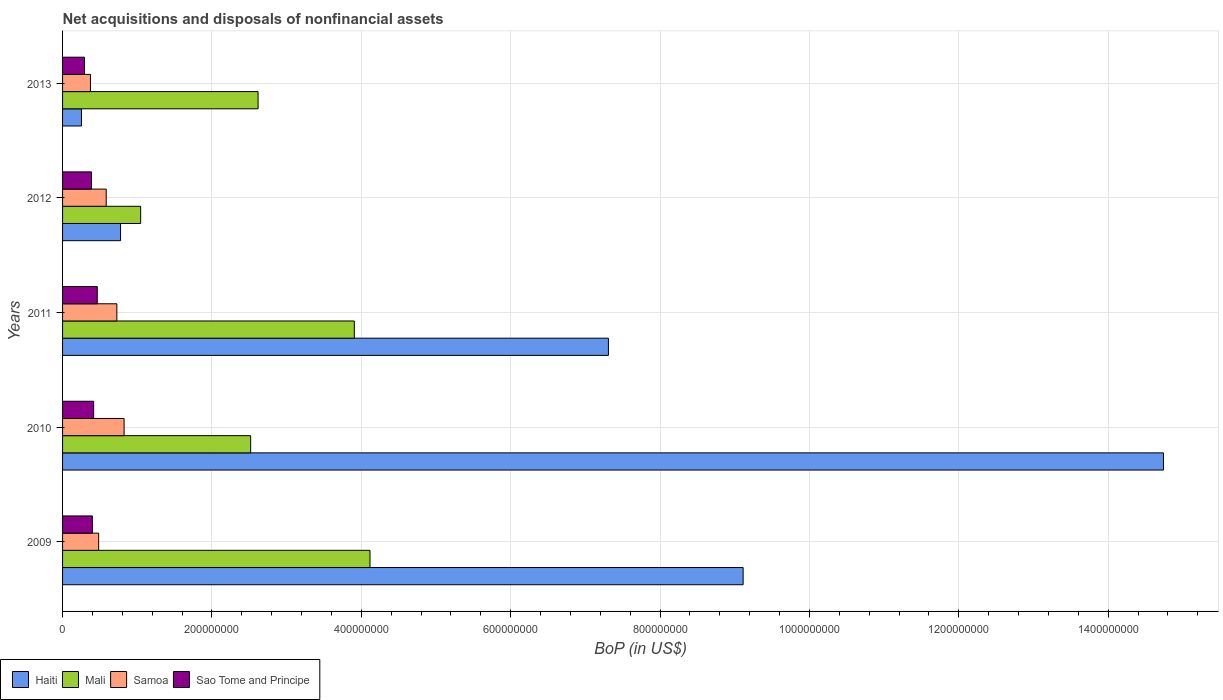How many groups of bars are there?
Your answer should be very brief. 5. Are the number of bars on each tick of the Y-axis equal?
Ensure brevity in your answer.  Yes. How many bars are there on the 3rd tick from the top?
Offer a very short reply. 4. How many bars are there on the 5th tick from the bottom?
Keep it short and to the point. 4. What is the Balance of Payments in Sao Tome and Principe in 2010?
Offer a terse response. 4.16e+07. Across all years, what is the maximum Balance of Payments in Mali?
Your answer should be very brief. 4.12e+08. Across all years, what is the minimum Balance of Payments in Mali?
Give a very brief answer. 1.05e+08. In which year was the Balance of Payments in Haiti maximum?
Ensure brevity in your answer.  2010. What is the total Balance of Payments in Mali in the graph?
Give a very brief answer. 1.42e+09. What is the difference between the Balance of Payments in Sao Tome and Principe in 2010 and that in 2013?
Give a very brief answer. 1.22e+07. What is the difference between the Balance of Payments in Haiti in 2011 and the Balance of Payments in Mali in 2012?
Offer a terse response. 6.26e+08. What is the average Balance of Payments in Sao Tome and Principe per year?
Keep it short and to the point. 3.92e+07. In the year 2012, what is the difference between the Balance of Payments in Samoa and Balance of Payments in Mali?
Offer a very short reply. -4.61e+07. In how many years, is the Balance of Payments in Samoa greater than 1200000000 US$?
Offer a terse response. 0. What is the ratio of the Balance of Payments in Mali in 2010 to that in 2011?
Offer a terse response. 0.64. Is the Balance of Payments in Mali in 2010 less than that in 2011?
Provide a short and direct response. Yes. Is the difference between the Balance of Payments in Samoa in 2009 and 2012 greater than the difference between the Balance of Payments in Mali in 2009 and 2012?
Offer a very short reply. No. What is the difference between the highest and the second highest Balance of Payments in Sao Tome and Principe?
Keep it short and to the point. 4.85e+06. What is the difference between the highest and the lowest Balance of Payments in Samoa?
Give a very brief answer. 4.50e+07. In how many years, is the Balance of Payments in Mali greater than the average Balance of Payments in Mali taken over all years?
Make the answer very short. 2. Is it the case that in every year, the sum of the Balance of Payments in Samoa and Balance of Payments in Sao Tome and Principe is greater than the sum of Balance of Payments in Mali and Balance of Payments in Haiti?
Offer a terse response. No. What does the 1st bar from the top in 2011 represents?
Your answer should be compact. Sao Tome and Principe. What does the 3rd bar from the bottom in 2010 represents?
Give a very brief answer. Samoa. How many bars are there?
Keep it short and to the point. 20. How many years are there in the graph?
Make the answer very short. 5. What is the difference between two consecutive major ticks on the X-axis?
Give a very brief answer. 2.00e+08. Are the values on the major ticks of X-axis written in scientific E-notation?
Your answer should be very brief. No. Does the graph contain grids?
Provide a short and direct response. Yes. How many legend labels are there?
Offer a terse response. 4. What is the title of the graph?
Provide a succinct answer. Net acquisitions and disposals of nonfinancial assets. Does "Sub-Saharan Africa (developing only)" appear as one of the legend labels in the graph?
Your answer should be compact. No. What is the label or title of the X-axis?
Offer a terse response. BoP (in US$). What is the label or title of the Y-axis?
Ensure brevity in your answer.  Years. What is the BoP (in US$) of Haiti in 2009?
Offer a very short reply. 9.11e+08. What is the BoP (in US$) in Mali in 2009?
Your answer should be compact. 4.12e+08. What is the BoP (in US$) of Samoa in 2009?
Ensure brevity in your answer.  4.83e+07. What is the BoP (in US$) of Sao Tome and Principe in 2009?
Make the answer very short. 3.99e+07. What is the BoP (in US$) of Haiti in 2010?
Your response must be concise. 1.47e+09. What is the BoP (in US$) in Mali in 2010?
Your response must be concise. 2.52e+08. What is the BoP (in US$) of Samoa in 2010?
Your answer should be compact. 8.24e+07. What is the BoP (in US$) of Sao Tome and Principe in 2010?
Keep it short and to the point. 4.16e+07. What is the BoP (in US$) in Haiti in 2011?
Provide a succinct answer. 7.31e+08. What is the BoP (in US$) of Mali in 2011?
Provide a short and direct response. 3.91e+08. What is the BoP (in US$) in Samoa in 2011?
Give a very brief answer. 7.27e+07. What is the BoP (in US$) in Sao Tome and Principe in 2011?
Keep it short and to the point. 4.65e+07. What is the BoP (in US$) in Haiti in 2012?
Offer a very short reply. 7.77e+07. What is the BoP (in US$) in Mali in 2012?
Make the answer very short. 1.05e+08. What is the BoP (in US$) of Samoa in 2012?
Make the answer very short. 5.84e+07. What is the BoP (in US$) of Sao Tome and Principe in 2012?
Ensure brevity in your answer.  3.87e+07. What is the BoP (in US$) in Haiti in 2013?
Provide a short and direct response. 2.53e+07. What is the BoP (in US$) of Mali in 2013?
Your response must be concise. 2.62e+08. What is the BoP (in US$) of Samoa in 2013?
Ensure brevity in your answer.  3.74e+07. What is the BoP (in US$) in Sao Tome and Principe in 2013?
Keep it short and to the point. 2.94e+07. Across all years, what is the maximum BoP (in US$) of Haiti?
Offer a terse response. 1.47e+09. Across all years, what is the maximum BoP (in US$) in Mali?
Keep it short and to the point. 4.12e+08. Across all years, what is the maximum BoP (in US$) of Samoa?
Offer a very short reply. 8.24e+07. Across all years, what is the maximum BoP (in US$) in Sao Tome and Principe?
Make the answer very short. 4.65e+07. Across all years, what is the minimum BoP (in US$) in Haiti?
Your response must be concise. 2.53e+07. Across all years, what is the minimum BoP (in US$) in Mali?
Give a very brief answer. 1.05e+08. Across all years, what is the minimum BoP (in US$) in Samoa?
Make the answer very short. 3.74e+07. Across all years, what is the minimum BoP (in US$) in Sao Tome and Principe?
Provide a succinct answer. 2.94e+07. What is the total BoP (in US$) in Haiti in the graph?
Your answer should be compact. 3.22e+09. What is the total BoP (in US$) of Mali in the graph?
Keep it short and to the point. 1.42e+09. What is the total BoP (in US$) of Samoa in the graph?
Provide a succinct answer. 2.99e+08. What is the total BoP (in US$) in Sao Tome and Principe in the graph?
Provide a short and direct response. 1.96e+08. What is the difference between the BoP (in US$) in Haiti in 2009 and that in 2010?
Ensure brevity in your answer.  -5.63e+08. What is the difference between the BoP (in US$) in Mali in 2009 and that in 2010?
Offer a very short reply. 1.60e+08. What is the difference between the BoP (in US$) in Samoa in 2009 and that in 2010?
Keep it short and to the point. -3.41e+07. What is the difference between the BoP (in US$) of Sao Tome and Principe in 2009 and that in 2010?
Your answer should be compact. -1.75e+06. What is the difference between the BoP (in US$) in Haiti in 2009 and that in 2011?
Make the answer very short. 1.80e+08. What is the difference between the BoP (in US$) of Mali in 2009 and that in 2011?
Provide a short and direct response. 2.10e+07. What is the difference between the BoP (in US$) in Samoa in 2009 and that in 2011?
Your response must be concise. -2.44e+07. What is the difference between the BoP (in US$) of Sao Tome and Principe in 2009 and that in 2011?
Your answer should be compact. -6.60e+06. What is the difference between the BoP (in US$) in Haiti in 2009 and that in 2012?
Your answer should be compact. 8.34e+08. What is the difference between the BoP (in US$) of Mali in 2009 and that in 2012?
Keep it short and to the point. 3.07e+08. What is the difference between the BoP (in US$) of Samoa in 2009 and that in 2012?
Offer a terse response. -1.01e+07. What is the difference between the BoP (in US$) in Sao Tome and Principe in 2009 and that in 2012?
Your response must be concise. 1.17e+06. What is the difference between the BoP (in US$) in Haiti in 2009 and that in 2013?
Provide a succinct answer. 8.86e+08. What is the difference between the BoP (in US$) in Mali in 2009 and that in 2013?
Your response must be concise. 1.50e+08. What is the difference between the BoP (in US$) in Samoa in 2009 and that in 2013?
Make the answer very short. 1.10e+07. What is the difference between the BoP (in US$) of Sao Tome and Principe in 2009 and that in 2013?
Give a very brief answer. 1.05e+07. What is the difference between the BoP (in US$) in Haiti in 2010 and that in 2011?
Keep it short and to the point. 7.43e+08. What is the difference between the BoP (in US$) in Mali in 2010 and that in 2011?
Make the answer very short. -1.39e+08. What is the difference between the BoP (in US$) of Samoa in 2010 and that in 2011?
Provide a short and direct response. 9.68e+06. What is the difference between the BoP (in US$) of Sao Tome and Principe in 2010 and that in 2011?
Your answer should be very brief. -4.85e+06. What is the difference between the BoP (in US$) in Haiti in 2010 and that in 2012?
Keep it short and to the point. 1.40e+09. What is the difference between the BoP (in US$) of Mali in 2010 and that in 2012?
Your response must be concise. 1.47e+08. What is the difference between the BoP (in US$) in Samoa in 2010 and that in 2012?
Provide a succinct answer. 2.39e+07. What is the difference between the BoP (in US$) of Sao Tome and Principe in 2010 and that in 2012?
Provide a short and direct response. 2.92e+06. What is the difference between the BoP (in US$) of Haiti in 2010 and that in 2013?
Provide a succinct answer. 1.45e+09. What is the difference between the BoP (in US$) in Mali in 2010 and that in 2013?
Keep it short and to the point. -9.95e+06. What is the difference between the BoP (in US$) of Samoa in 2010 and that in 2013?
Keep it short and to the point. 4.50e+07. What is the difference between the BoP (in US$) of Sao Tome and Principe in 2010 and that in 2013?
Ensure brevity in your answer.  1.22e+07. What is the difference between the BoP (in US$) in Haiti in 2011 and that in 2012?
Your answer should be compact. 6.53e+08. What is the difference between the BoP (in US$) in Mali in 2011 and that in 2012?
Your answer should be compact. 2.86e+08. What is the difference between the BoP (in US$) of Samoa in 2011 and that in 2012?
Offer a terse response. 1.42e+07. What is the difference between the BoP (in US$) in Sao Tome and Principe in 2011 and that in 2012?
Keep it short and to the point. 7.77e+06. What is the difference between the BoP (in US$) in Haiti in 2011 and that in 2013?
Your response must be concise. 7.06e+08. What is the difference between the BoP (in US$) of Mali in 2011 and that in 2013?
Your answer should be compact. 1.29e+08. What is the difference between the BoP (in US$) in Samoa in 2011 and that in 2013?
Make the answer very short. 3.53e+07. What is the difference between the BoP (in US$) of Sao Tome and Principe in 2011 and that in 2013?
Your answer should be compact. 1.71e+07. What is the difference between the BoP (in US$) in Haiti in 2012 and that in 2013?
Offer a very short reply. 5.24e+07. What is the difference between the BoP (in US$) of Mali in 2012 and that in 2013?
Keep it short and to the point. -1.57e+08. What is the difference between the BoP (in US$) of Samoa in 2012 and that in 2013?
Give a very brief answer. 2.11e+07. What is the difference between the BoP (in US$) in Sao Tome and Principe in 2012 and that in 2013?
Ensure brevity in your answer.  9.30e+06. What is the difference between the BoP (in US$) in Haiti in 2009 and the BoP (in US$) in Mali in 2010?
Provide a succinct answer. 6.59e+08. What is the difference between the BoP (in US$) in Haiti in 2009 and the BoP (in US$) in Samoa in 2010?
Your response must be concise. 8.29e+08. What is the difference between the BoP (in US$) of Haiti in 2009 and the BoP (in US$) of Sao Tome and Principe in 2010?
Keep it short and to the point. 8.70e+08. What is the difference between the BoP (in US$) in Mali in 2009 and the BoP (in US$) in Samoa in 2010?
Keep it short and to the point. 3.29e+08. What is the difference between the BoP (in US$) in Mali in 2009 and the BoP (in US$) in Sao Tome and Principe in 2010?
Your answer should be compact. 3.70e+08. What is the difference between the BoP (in US$) in Samoa in 2009 and the BoP (in US$) in Sao Tome and Principe in 2010?
Offer a terse response. 6.68e+06. What is the difference between the BoP (in US$) in Haiti in 2009 and the BoP (in US$) in Mali in 2011?
Keep it short and to the point. 5.21e+08. What is the difference between the BoP (in US$) of Haiti in 2009 and the BoP (in US$) of Samoa in 2011?
Provide a short and direct response. 8.39e+08. What is the difference between the BoP (in US$) in Haiti in 2009 and the BoP (in US$) in Sao Tome and Principe in 2011?
Make the answer very short. 8.65e+08. What is the difference between the BoP (in US$) in Mali in 2009 and the BoP (in US$) in Samoa in 2011?
Provide a short and direct response. 3.39e+08. What is the difference between the BoP (in US$) of Mali in 2009 and the BoP (in US$) of Sao Tome and Principe in 2011?
Your answer should be very brief. 3.65e+08. What is the difference between the BoP (in US$) of Samoa in 2009 and the BoP (in US$) of Sao Tome and Principe in 2011?
Give a very brief answer. 1.83e+06. What is the difference between the BoP (in US$) of Haiti in 2009 and the BoP (in US$) of Mali in 2012?
Make the answer very short. 8.07e+08. What is the difference between the BoP (in US$) in Haiti in 2009 and the BoP (in US$) in Samoa in 2012?
Keep it short and to the point. 8.53e+08. What is the difference between the BoP (in US$) of Haiti in 2009 and the BoP (in US$) of Sao Tome and Principe in 2012?
Offer a very short reply. 8.73e+08. What is the difference between the BoP (in US$) in Mali in 2009 and the BoP (in US$) in Samoa in 2012?
Give a very brief answer. 3.53e+08. What is the difference between the BoP (in US$) in Mali in 2009 and the BoP (in US$) in Sao Tome and Principe in 2012?
Make the answer very short. 3.73e+08. What is the difference between the BoP (in US$) of Samoa in 2009 and the BoP (in US$) of Sao Tome and Principe in 2012?
Keep it short and to the point. 9.60e+06. What is the difference between the BoP (in US$) in Haiti in 2009 and the BoP (in US$) in Mali in 2013?
Offer a very short reply. 6.49e+08. What is the difference between the BoP (in US$) in Haiti in 2009 and the BoP (in US$) in Samoa in 2013?
Your answer should be compact. 8.74e+08. What is the difference between the BoP (in US$) in Haiti in 2009 and the BoP (in US$) in Sao Tome and Principe in 2013?
Your answer should be compact. 8.82e+08. What is the difference between the BoP (in US$) of Mali in 2009 and the BoP (in US$) of Samoa in 2013?
Your response must be concise. 3.74e+08. What is the difference between the BoP (in US$) in Mali in 2009 and the BoP (in US$) in Sao Tome and Principe in 2013?
Provide a succinct answer. 3.82e+08. What is the difference between the BoP (in US$) in Samoa in 2009 and the BoP (in US$) in Sao Tome and Principe in 2013?
Your response must be concise. 1.89e+07. What is the difference between the BoP (in US$) of Haiti in 2010 and the BoP (in US$) of Mali in 2011?
Keep it short and to the point. 1.08e+09. What is the difference between the BoP (in US$) of Haiti in 2010 and the BoP (in US$) of Samoa in 2011?
Your answer should be very brief. 1.40e+09. What is the difference between the BoP (in US$) in Haiti in 2010 and the BoP (in US$) in Sao Tome and Principe in 2011?
Offer a terse response. 1.43e+09. What is the difference between the BoP (in US$) of Mali in 2010 and the BoP (in US$) of Samoa in 2011?
Provide a succinct answer. 1.79e+08. What is the difference between the BoP (in US$) in Mali in 2010 and the BoP (in US$) in Sao Tome and Principe in 2011?
Make the answer very short. 2.05e+08. What is the difference between the BoP (in US$) in Samoa in 2010 and the BoP (in US$) in Sao Tome and Principe in 2011?
Your answer should be compact. 3.59e+07. What is the difference between the BoP (in US$) in Haiti in 2010 and the BoP (in US$) in Mali in 2012?
Ensure brevity in your answer.  1.37e+09. What is the difference between the BoP (in US$) of Haiti in 2010 and the BoP (in US$) of Samoa in 2012?
Offer a terse response. 1.42e+09. What is the difference between the BoP (in US$) of Haiti in 2010 and the BoP (in US$) of Sao Tome and Principe in 2012?
Provide a succinct answer. 1.44e+09. What is the difference between the BoP (in US$) in Mali in 2010 and the BoP (in US$) in Samoa in 2012?
Make the answer very short. 1.93e+08. What is the difference between the BoP (in US$) of Mali in 2010 and the BoP (in US$) of Sao Tome and Principe in 2012?
Your answer should be very brief. 2.13e+08. What is the difference between the BoP (in US$) of Samoa in 2010 and the BoP (in US$) of Sao Tome and Principe in 2012?
Provide a short and direct response. 4.37e+07. What is the difference between the BoP (in US$) in Haiti in 2010 and the BoP (in US$) in Mali in 2013?
Offer a very short reply. 1.21e+09. What is the difference between the BoP (in US$) of Haiti in 2010 and the BoP (in US$) of Samoa in 2013?
Offer a very short reply. 1.44e+09. What is the difference between the BoP (in US$) of Haiti in 2010 and the BoP (in US$) of Sao Tome and Principe in 2013?
Keep it short and to the point. 1.44e+09. What is the difference between the BoP (in US$) of Mali in 2010 and the BoP (in US$) of Samoa in 2013?
Provide a succinct answer. 2.14e+08. What is the difference between the BoP (in US$) of Mali in 2010 and the BoP (in US$) of Sao Tome and Principe in 2013?
Your answer should be very brief. 2.22e+08. What is the difference between the BoP (in US$) in Samoa in 2010 and the BoP (in US$) in Sao Tome and Principe in 2013?
Offer a very short reply. 5.30e+07. What is the difference between the BoP (in US$) of Haiti in 2011 and the BoP (in US$) of Mali in 2012?
Provide a succinct answer. 6.26e+08. What is the difference between the BoP (in US$) of Haiti in 2011 and the BoP (in US$) of Samoa in 2012?
Provide a short and direct response. 6.72e+08. What is the difference between the BoP (in US$) of Haiti in 2011 and the BoP (in US$) of Sao Tome and Principe in 2012?
Make the answer very short. 6.92e+08. What is the difference between the BoP (in US$) of Mali in 2011 and the BoP (in US$) of Samoa in 2012?
Make the answer very short. 3.32e+08. What is the difference between the BoP (in US$) in Mali in 2011 and the BoP (in US$) in Sao Tome and Principe in 2012?
Offer a terse response. 3.52e+08. What is the difference between the BoP (in US$) in Samoa in 2011 and the BoP (in US$) in Sao Tome and Principe in 2012?
Keep it short and to the point. 3.40e+07. What is the difference between the BoP (in US$) of Haiti in 2011 and the BoP (in US$) of Mali in 2013?
Your answer should be compact. 4.69e+08. What is the difference between the BoP (in US$) in Haiti in 2011 and the BoP (in US$) in Samoa in 2013?
Give a very brief answer. 6.94e+08. What is the difference between the BoP (in US$) of Haiti in 2011 and the BoP (in US$) of Sao Tome and Principe in 2013?
Your answer should be compact. 7.01e+08. What is the difference between the BoP (in US$) of Mali in 2011 and the BoP (in US$) of Samoa in 2013?
Provide a succinct answer. 3.53e+08. What is the difference between the BoP (in US$) of Mali in 2011 and the BoP (in US$) of Sao Tome and Principe in 2013?
Ensure brevity in your answer.  3.61e+08. What is the difference between the BoP (in US$) in Samoa in 2011 and the BoP (in US$) in Sao Tome and Principe in 2013?
Provide a succinct answer. 4.33e+07. What is the difference between the BoP (in US$) of Haiti in 2012 and the BoP (in US$) of Mali in 2013?
Your answer should be very brief. -1.84e+08. What is the difference between the BoP (in US$) of Haiti in 2012 and the BoP (in US$) of Samoa in 2013?
Your response must be concise. 4.03e+07. What is the difference between the BoP (in US$) of Haiti in 2012 and the BoP (in US$) of Sao Tome and Principe in 2013?
Provide a short and direct response. 4.82e+07. What is the difference between the BoP (in US$) of Mali in 2012 and the BoP (in US$) of Samoa in 2013?
Keep it short and to the point. 6.72e+07. What is the difference between the BoP (in US$) of Mali in 2012 and the BoP (in US$) of Sao Tome and Principe in 2013?
Your response must be concise. 7.51e+07. What is the difference between the BoP (in US$) of Samoa in 2012 and the BoP (in US$) of Sao Tome and Principe in 2013?
Keep it short and to the point. 2.90e+07. What is the average BoP (in US$) of Haiti per year?
Your answer should be compact. 6.44e+08. What is the average BoP (in US$) in Mali per year?
Make the answer very short. 2.84e+08. What is the average BoP (in US$) of Samoa per year?
Provide a succinct answer. 5.98e+07. What is the average BoP (in US$) of Sao Tome and Principe per year?
Keep it short and to the point. 3.92e+07. In the year 2009, what is the difference between the BoP (in US$) in Haiti and BoP (in US$) in Mali?
Ensure brevity in your answer.  5.00e+08. In the year 2009, what is the difference between the BoP (in US$) in Haiti and BoP (in US$) in Samoa?
Make the answer very short. 8.63e+08. In the year 2009, what is the difference between the BoP (in US$) of Haiti and BoP (in US$) of Sao Tome and Principe?
Offer a terse response. 8.71e+08. In the year 2009, what is the difference between the BoP (in US$) of Mali and BoP (in US$) of Samoa?
Your answer should be very brief. 3.63e+08. In the year 2009, what is the difference between the BoP (in US$) in Mali and BoP (in US$) in Sao Tome and Principe?
Your answer should be compact. 3.72e+08. In the year 2009, what is the difference between the BoP (in US$) in Samoa and BoP (in US$) in Sao Tome and Principe?
Provide a short and direct response. 8.43e+06. In the year 2010, what is the difference between the BoP (in US$) in Haiti and BoP (in US$) in Mali?
Ensure brevity in your answer.  1.22e+09. In the year 2010, what is the difference between the BoP (in US$) in Haiti and BoP (in US$) in Samoa?
Provide a short and direct response. 1.39e+09. In the year 2010, what is the difference between the BoP (in US$) of Haiti and BoP (in US$) of Sao Tome and Principe?
Your response must be concise. 1.43e+09. In the year 2010, what is the difference between the BoP (in US$) of Mali and BoP (in US$) of Samoa?
Your answer should be very brief. 1.69e+08. In the year 2010, what is the difference between the BoP (in US$) in Mali and BoP (in US$) in Sao Tome and Principe?
Your response must be concise. 2.10e+08. In the year 2010, what is the difference between the BoP (in US$) in Samoa and BoP (in US$) in Sao Tome and Principe?
Provide a succinct answer. 4.07e+07. In the year 2011, what is the difference between the BoP (in US$) in Haiti and BoP (in US$) in Mali?
Make the answer very short. 3.40e+08. In the year 2011, what is the difference between the BoP (in US$) in Haiti and BoP (in US$) in Samoa?
Ensure brevity in your answer.  6.58e+08. In the year 2011, what is the difference between the BoP (in US$) of Haiti and BoP (in US$) of Sao Tome and Principe?
Keep it short and to the point. 6.84e+08. In the year 2011, what is the difference between the BoP (in US$) of Mali and BoP (in US$) of Samoa?
Give a very brief answer. 3.18e+08. In the year 2011, what is the difference between the BoP (in US$) in Mali and BoP (in US$) in Sao Tome and Principe?
Your response must be concise. 3.44e+08. In the year 2011, what is the difference between the BoP (in US$) of Samoa and BoP (in US$) of Sao Tome and Principe?
Ensure brevity in your answer.  2.62e+07. In the year 2012, what is the difference between the BoP (in US$) in Haiti and BoP (in US$) in Mali?
Your answer should be compact. -2.69e+07. In the year 2012, what is the difference between the BoP (in US$) of Haiti and BoP (in US$) of Samoa?
Provide a short and direct response. 1.92e+07. In the year 2012, what is the difference between the BoP (in US$) in Haiti and BoP (in US$) in Sao Tome and Principe?
Keep it short and to the point. 3.89e+07. In the year 2012, what is the difference between the BoP (in US$) in Mali and BoP (in US$) in Samoa?
Offer a very short reply. 4.61e+07. In the year 2012, what is the difference between the BoP (in US$) of Mali and BoP (in US$) of Sao Tome and Principe?
Ensure brevity in your answer.  6.58e+07. In the year 2012, what is the difference between the BoP (in US$) in Samoa and BoP (in US$) in Sao Tome and Principe?
Offer a very short reply. 1.97e+07. In the year 2013, what is the difference between the BoP (in US$) of Haiti and BoP (in US$) of Mali?
Your answer should be compact. -2.37e+08. In the year 2013, what is the difference between the BoP (in US$) of Haiti and BoP (in US$) of Samoa?
Provide a succinct answer. -1.21e+07. In the year 2013, what is the difference between the BoP (in US$) in Haiti and BoP (in US$) in Sao Tome and Principe?
Give a very brief answer. -4.13e+06. In the year 2013, what is the difference between the BoP (in US$) in Mali and BoP (in US$) in Samoa?
Your answer should be very brief. 2.24e+08. In the year 2013, what is the difference between the BoP (in US$) of Mali and BoP (in US$) of Sao Tome and Principe?
Provide a short and direct response. 2.32e+08. In the year 2013, what is the difference between the BoP (in US$) in Samoa and BoP (in US$) in Sao Tome and Principe?
Keep it short and to the point. 7.93e+06. What is the ratio of the BoP (in US$) of Haiti in 2009 to that in 2010?
Ensure brevity in your answer.  0.62. What is the ratio of the BoP (in US$) of Mali in 2009 to that in 2010?
Offer a very short reply. 1.63. What is the ratio of the BoP (in US$) of Samoa in 2009 to that in 2010?
Your answer should be very brief. 0.59. What is the ratio of the BoP (in US$) in Sao Tome and Principe in 2009 to that in 2010?
Your answer should be compact. 0.96. What is the ratio of the BoP (in US$) in Haiti in 2009 to that in 2011?
Make the answer very short. 1.25. What is the ratio of the BoP (in US$) in Mali in 2009 to that in 2011?
Offer a terse response. 1.05. What is the ratio of the BoP (in US$) of Samoa in 2009 to that in 2011?
Your answer should be very brief. 0.66. What is the ratio of the BoP (in US$) in Sao Tome and Principe in 2009 to that in 2011?
Your answer should be very brief. 0.86. What is the ratio of the BoP (in US$) of Haiti in 2009 to that in 2012?
Provide a short and direct response. 11.74. What is the ratio of the BoP (in US$) in Mali in 2009 to that in 2012?
Your answer should be compact. 3.94. What is the ratio of the BoP (in US$) of Samoa in 2009 to that in 2012?
Offer a terse response. 0.83. What is the ratio of the BoP (in US$) of Sao Tome and Principe in 2009 to that in 2012?
Provide a short and direct response. 1.03. What is the ratio of the BoP (in US$) in Haiti in 2009 to that in 2013?
Provide a succinct answer. 36.04. What is the ratio of the BoP (in US$) of Mali in 2009 to that in 2013?
Provide a succinct answer. 1.57. What is the ratio of the BoP (in US$) of Samoa in 2009 to that in 2013?
Offer a terse response. 1.29. What is the ratio of the BoP (in US$) of Sao Tome and Principe in 2009 to that in 2013?
Offer a very short reply. 1.36. What is the ratio of the BoP (in US$) of Haiti in 2010 to that in 2011?
Provide a short and direct response. 2.02. What is the ratio of the BoP (in US$) of Mali in 2010 to that in 2011?
Provide a short and direct response. 0.64. What is the ratio of the BoP (in US$) in Samoa in 2010 to that in 2011?
Provide a short and direct response. 1.13. What is the ratio of the BoP (in US$) of Sao Tome and Principe in 2010 to that in 2011?
Your answer should be compact. 0.9. What is the ratio of the BoP (in US$) in Haiti in 2010 to that in 2012?
Your answer should be compact. 18.98. What is the ratio of the BoP (in US$) in Mali in 2010 to that in 2012?
Your answer should be compact. 2.41. What is the ratio of the BoP (in US$) in Samoa in 2010 to that in 2012?
Give a very brief answer. 1.41. What is the ratio of the BoP (in US$) of Sao Tome and Principe in 2010 to that in 2012?
Offer a very short reply. 1.08. What is the ratio of the BoP (in US$) in Haiti in 2010 to that in 2013?
Provide a succinct answer. 58.3. What is the ratio of the BoP (in US$) in Mali in 2010 to that in 2013?
Provide a short and direct response. 0.96. What is the ratio of the BoP (in US$) of Samoa in 2010 to that in 2013?
Provide a short and direct response. 2.21. What is the ratio of the BoP (in US$) of Sao Tome and Principe in 2010 to that in 2013?
Keep it short and to the point. 1.42. What is the ratio of the BoP (in US$) in Haiti in 2011 to that in 2012?
Your response must be concise. 9.41. What is the ratio of the BoP (in US$) of Mali in 2011 to that in 2012?
Make the answer very short. 3.74. What is the ratio of the BoP (in US$) in Samoa in 2011 to that in 2012?
Your answer should be compact. 1.24. What is the ratio of the BoP (in US$) in Sao Tome and Principe in 2011 to that in 2012?
Ensure brevity in your answer.  1.2. What is the ratio of the BoP (in US$) of Haiti in 2011 to that in 2013?
Provide a succinct answer. 28.9. What is the ratio of the BoP (in US$) of Mali in 2011 to that in 2013?
Provide a succinct answer. 1.49. What is the ratio of the BoP (in US$) in Samoa in 2011 to that in 2013?
Your answer should be compact. 1.95. What is the ratio of the BoP (in US$) in Sao Tome and Principe in 2011 to that in 2013?
Your response must be concise. 1.58. What is the ratio of the BoP (in US$) in Haiti in 2012 to that in 2013?
Offer a terse response. 3.07. What is the ratio of the BoP (in US$) of Mali in 2012 to that in 2013?
Offer a very short reply. 0.4. What is the ratio of the BoP (in US$) in Samoa in 2012 to that in 2013?
Provide a succinct answer. 1.56. What is the ratio of the BoP (in US$) in Sao Tome and Principe in 2012 to that in 2013?
Offer a very short reply. 1.32. What is the difference between the highest and the second highest BoP (in US$) of Haiti?
Ensure brevity in your answer.  5.63e+08. What is the difference between the highest and the second highest BoP (in US$) in Mali?
Provide a succinct answer. 2.10e+07. What is the difference between the highest and the second highest BoP (in US$) in Samoa?
Provide a succinct answer. 9.68e+06. What is the difference between the highest and the second highest BoP (in US$) of Sao Tome and Principe?
Provide a short and direct response. 4.85e+06. What is the difference between the highest and the lowest BoP (in US$) in Haiti?
Offer a very short reply. 1.45e+09. What is the difference between the highest and the lowest BoP (in US$) of Mali?
Provide a short and direct response. 3.07e+08. What is the difference between the highest and the lowest BoP (in US$) in Samoa?
Ensure brevity in your answer.  4.50e+07. What is the difference between the highest and the lowest BoP (in US$) of Sao Tome and Principe?
Provide a succinct answer. 1.71e+07. 